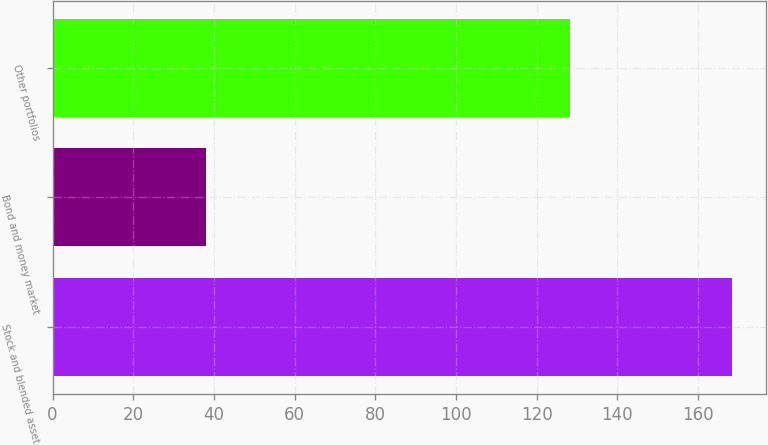<chart> <loc_0><loc_0><loc_500><loc_500><bar_chart><fcel>Stock and blended asset<fcel>Bond and money market<fcel>Other portfolios<nl><fcel>168.5<fcel>38<fcel>128.2<nl></chart> 